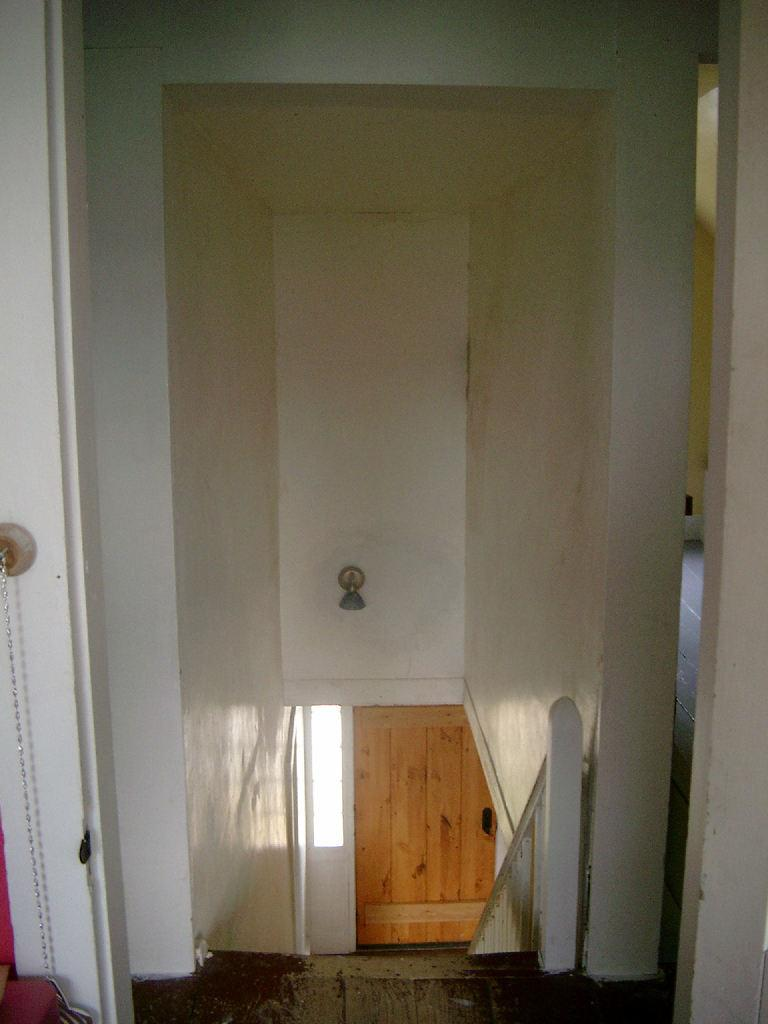What language is the slave speaking during the week in the image? There is no image, and therefore no context to determine if there is a slave or any language being spoken during the week. 